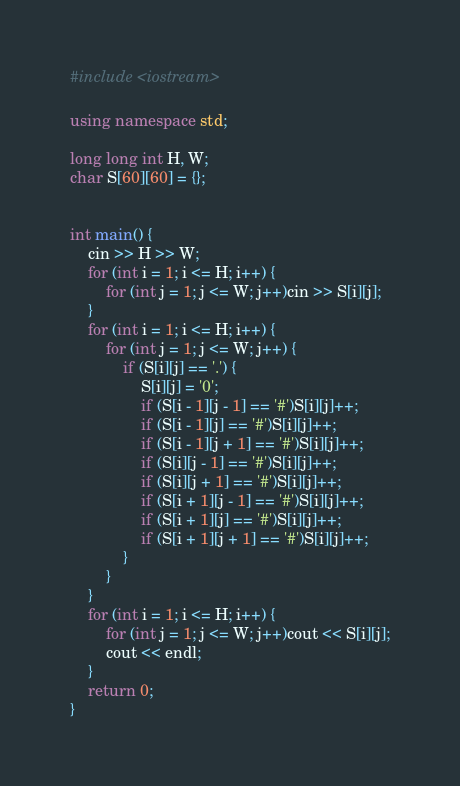Convert code to text. <code><loc_0><loc_0><loc_500><loc_500><_C++_>#include <iostream>

using namespace std;

long long int H, W;
char S[60][60] = {};


int main() {
	cin >> H >> W;
	for (int i = 1; i <= H; i++) {
		for (int j = 1; j <= W; j++)cin >> S[i][j];
	}
	for (int i = 1; i <= H; i++) {
		for (int j = 1; j <= W; j++) {
			if (S[i][j] == '.') {
				S[i][j] = '0';
				if (S[i - 1][j - 1] == '#')S[i][j]++;
				if (S[i - 1][j] == '#')S[i][j]++;
				if (S[i - 1][j + 1] == '#')S[i][j]++;
				if (S[i][j - 1] == '#')S[i][j]++;
				if (S[i][j + 1] == '#')S[i][j]++;
				if (S[i + 1][j - 1] == '#')S[i][j]++;
				if (S[i + 1][j] == '#')S[i][j]++;
				if (S[i + 1][j + 1] == '#')S[i][j]++;
			}
		}
	}
	for (int i = 1; i <= H; i++) {
		for (int j = 1; j <= W; j++)cout << S[i][j];
		cout << endl;
	}
	return 0;
}</code> 